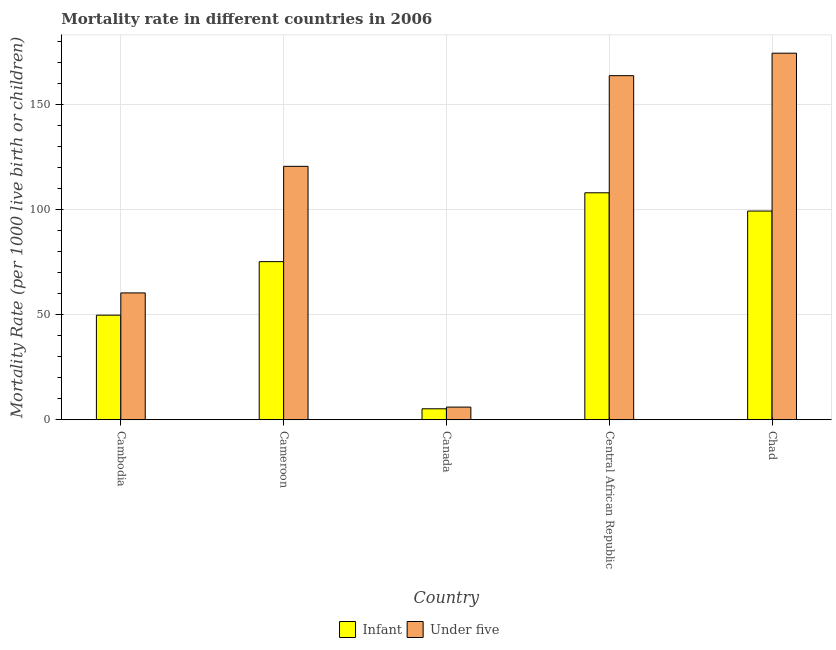How many groups of bars are there?
Give a very brief answer. 5. Are the number of bars on each tick of the X-axis equal?
Your answer should be very brief. Yes. In how many cases, is the number of bars for a given country not equal to the number of legend labels?
Give a very brief answer. 0. What is the infant mortality rate in Canada?
Your answer should be compact. 5.2. Across all countries, what is the maximum infant mortality rate?
Offer a very short reply. 108.1. Across all countries, what is the minimum under-5 mortality rate?
Provide a short and direct response. 6. In which country was the infant mortality rate maximum?
Offer a terse response. Central African Republic. What is the total infant mortality rate in the graph?
Provide a short and direct response. 337.8. What is the difference between the under-5 mortality rate in Central African Republic and that in Chad?
Provide a short and direct response. -10.7. What is the difference between the infant mortality rate in Cambodia and the under-5 mortality rate in Cameroon?
Provide a succinct answer. -70.9. What is the average infant mortality rate per country?
Make the answer very short. 67.56. What is the difference between the under-5 mortality rate and infant mortality rate in Central African Republic?
Ensure brevity in your answer.  55.8. In how many countries, is the under-5 mortality rate greater than 50 ?
Provide a short and direct response. 4. What is the ratio of the infant mortality rate in Cameroon to that in Canada?
Offer a very short reply. 14.48. Is the infant mortality rate in Cameroon less than that in Central African Republic?
Provide a succinct answer. Yes. Is the difference between the infant mortality rate in Cambodia and Chad greater than the difference between the under-5 mortality rate in Cambodia and Chad?
Ensure brevity in your answer.  Yes. What is the difference between the highest and the second highest under-5 mortality rate?
Your answer should be compact. 10.7. What is the difference between the highest and the lowest under-5 mortality rate?
Provide a short and direct response. 168.6. In how many countries, is the infant mortality rate greater than the average infant mortality rate taken over all countries?
Provide a succinct answer. 3. What does the 2nd bar from the left in Canada represents?
Give a very brief answer. Under five. What does the 2nd bar from the right in Cambodia represents?
Keep it short and to the point. Infant. How many bars are there?
Keep it short and to the point. 10. Are all the bars in the graph horizontal?
Your answer should be compact. No. How many countries are there in the graph?
Provide a short and direct response. 5. What is the difference between two consecutive major ticks on the Y-axis?
Your answer should be very brief. 50. Does the graph contain any zero values?
Your response must be concise. No. Does the graph contain grids?
Provide a succinct answer. Yes. Where does the legend appear in the graph?
Keep it short and to the point. Bottom center. How many legend labels are there?
Make the answer very short. 2. How are the legend labels stacked?
Offer a very short reply. Horizontal. What is the title of the graph?
Your answer should be very brief. Mortality rate in different countries in 2006. What is the label or title of the Y-axis?
Ensure brevity in your answer.  Mortality Rate (per 1000 live birth or children). What is the Mortality Rate (per 1000 live birth or children) in Infant in Cambodia?
Offer a very short reply. 49.8. What is the Mortality Rate (per 1000 live birth or children) of Under five in Cambodia?
Offer a terse response. 60.4. What is the Mortality Rate (per 1000 live birth or children) of Infant in Cameroon?
Your answer should be very brief. 75.3. What is the Mortality Rate (per 1000 live birth or children) of Under five in Cameroon?
Your response must be concise. 120.7. What is the Mortality Rate (per 1000 live birth or children) of Infant in Canada?
Your answer should be very brief. 5.2. What is the Mortality Rate (per 1000 live birth or children) of Infant in Central African Republic?
Make the answer very short. 108.1. What is the Mortality Rate (per 1000 live birth or children) in Under five in Central African Republic?
Your answer should be compact. 163.9. What is the Mortality Rate (per 1000 live birth or children) in Infant in Chad?
Offer a terse response. 99.4. What is the Mortality Rate (per 1000 live birth or children) of Under five in Chad?
Provide a succinct answer. 174.6. Across all countries, what is the maximum Mortality Rate (per 1000 live birth or children) of Infant?
Make the answer very short. 108.1. Across all countries, what is the maximum Mortality Rate (per 1000 live birth or children) of Under five?
Keep it short and to the point. 174.6. What is the total Mortality Rate (per 1000 live birth or children) in Infant in the graph?
Make the answer very short. 337.8. What is the total Mortality Rate (per 1000 live birth or children) of Under five in the graph?
Give a very brief answer. 525.6. What is the difference between the Mortality Rate (per 1000 live birth or children) of Infant in Cambodia and that in Cameroon?
Your answer should be very brief. -25.5. What is the difference between the Mortality Rate (per 1000 live birth or children) of Under five in Cambodia and that in Cameroon?
Keep it short and to the point. -60.3. What is the difference between the Mortality Rate (per 1000 live birth or children) in Infant in Cambodia and that in Canada?
Offer a terse response. 44.6. What is the difference between the Mortality Rate (per 1000 live birth or children) of Under five in Cambodia and that in Canada?
Provide a short and direct response. 54.4. What is the difference between the Mortality Rate (per 1000 live birth or children) of Infant in Cambodia and that in Central African Republic?
Your answer should be compact. -58.3. What is the difference between the Mortality Rate (per 1000 live birth or children) in Under five in Cambodia and that in Central African Republic?
Your answer should be compact. -103.5. What is the difference between the Mortality Rate (per 1000 live birth or children) in Infant in Cambodia and that in Chad?
Your response must be concise. -49.6. What is the difference between the Mortality Rate (per 1000 live birth or children) in Under five in Cambodia and that in Chad?
Keep it short and to the point. -114.2. What is the difference between the Mortality Rate (per 1000 live birth or children) in Infant in Cameroon and that in Canada?
Your response must be concise. 70.1. What is the difference between the Mortality Rate (per 1000 live birth or children) of Under five in Cameroon and that in Canada?
Ensure brevity in your answer.  114.7. What is the difference between the Mortality Rate (per 1000 live birth or children) in Infant in Cameroon and that in Central African Republic?
Provide a short and direct response. -32.8. What is the difference between the Mortality Rate (per 1000 live birth or children) in Under five in Cameroon and that in Central African Republic?
Offer a terse response. -43.2. What is the difference between the Mortality Rate (per 1000 live birth or children) of Infant in Cameroon and that in Chad?
Give a very brief answer. -24.1. What is the difference between the Mortality Rate (per 1000 live birth or children) of Under five in Cameroon and that in Chad?
Ensure brevity in your answer.  -53.9. What is the difference between the Mortality Rate (per 1000 live birth or children) in Infant in Canada and that in Central African Republic?
Keep it short and to the point. -102.9. What is the difference between the Mortality Rate (per 1000 live birth or children) of Under five in Canada and that in Central African Republic?
Provide a short and direct response. -157.9. What is the difference between the Mortality Rate (per 1000 live birth or children) of Infant in Canada and that in Chad?
Provide a short and direct response. -94.2. What is the difference between the Mortality Rate (per 1000 live birth or children) of Under five in Canada and that in Chad?
Offer a very short reply. -168.6. What is the difference between the Mortality Rate (per 1000 live birth or children) of Under five in Central African Republic and that in Chad?
Provide a succinct answer. -10.7. What is the difference between the Mortality Rate (per 1000 live birth or children) in Infant in Cambodia and the Mortality Rate (per 1000 live birth or children) in Under five in Cameroon?
Offer a very short reply. -70.9. What is the difference between the Mortality Rate (per 1000 live birth or children) in Infant in Cambodia and the Mortality Rate (per 1000 live birth or children) in Under five in Canada?
Your response must be concise. 43.8. What is the difference between the Mortality Rate (per 1000 live birth or children) of Infant in Cambodia and the Mortality Rate (per 1000 live birth or children) of Under five in Central African Republic?
Provide a short and direct response. -114.1. What is the difference between the Mortality Rate (per 1000 live birth or children) in Infant in Cambodia and the Mortality Rate (per 1000 live birth or children) in Under five in Chad?
Ensure brevity in your answer.  -124.8. What is the difference between the Mortality Rate (per 1000 live birth or children) of Infant in Cameroon and the Mortality Rate (per 1000 live birth or children) of Under five in Canada?
Offer a terse response. 69.3. What is the difference between the Mortality Rate (per 1000 live birth or children) of Infant in Cameroon and the Mortality Rate (per 1000 live birth or children) of Under five in Central African Republic?
Keep it short and to the point. -88.6. What is the difference between the Mortality Rate (per 1000 live birth or children) in Infant in Cameroon and the Mortality Rate (per 1000 live birth or children) in Under five in Chad?
Keep it short and to the point. -99.3. What is the difference between the Mortality Rate (per 1000 live birth or children) in Infant in Canada and the Mortality Rate (per 1000 live birth or children) in Under five in Central African Republic?
Offer a terse response. -158.7. What is the difference between the Mortality Rate (per 1000 live birth or children) of Infant in Canada and the Mortality Rate (per 1000 live birth or children) of Under five in Chad?
Your answer should be compact. -169.4. What is the difference between the Mortality Rate (per 1000 live birth or children) in Infant in Central African Republic and the Mortality Rate (per 1000 live birth or children) in Under five in Chad?
Your response must be concise. -66.5. What is the average Mortality Rate (per 1000 live birth or children) of Infant per country?
Offer a very short reply. 67.56. What is the average Mortality Rate (per 1000 live birth or children) in Under five per country?
Offer a terse response. 105.12. What is the difference between the Mortality Rate (per 1000 live birth or children) in Infant and Mortality Rate (per 1000 live birth or children) in Under five in Cambodia?
Your answer should be compact. -10.6. What is the difference between the Mortality Rate (per 1000 live birth or children) in Infant and Mortality Rate (per 1000 live birth or children) in Under five in Cameroon?
Keep it short and to the point. -45.4. What is the difference between the Mortality Rate (per 1000 live birth or children) of Infant and Mortality Rate (per 1000 live birth or children) of Under five in Canada?
Give a very brief answer. -0.8. What is the difference between the Mortality Rate (per 1000 live birth or children) in Infant and Mortality Rate (per 1000 live birth or children) in Under five in Central African Republic?
Your answer should be compact. -55.8. What is the difference between the Mortality Rate (per 1000 live birth or children) in Infant and Mortality Rate (per 1000 live birth or children) in Under five in Chad?
Give a very brief answer. -75.2. What is the ratio of the Mortality Rate (per 1000 live birth or children) of Infant in Cambodia to that in Cameroon?
Your answer should be very brief. 0.66. What is the ratio of the Mortality Rate (per 1000 live birth or children) of Under five in Cambodia to that in Cameroon?
Your response must be concise. 0.5. What is the ratio of the Mortality Rate (per 1000 live birth or children) in Infant in Cambodia to that in Canada?
Give a very brief answer. 9.58. What is the ratio of the Mortality Rate (per 1000 live birth or children) of Under five in Cambodia to that in Canada?
Provide a short and direct response. 10.07. What is the ratio of the Mortality Rate (per 1000 live birth or children) in Infant in Cambodia to that in Central African Republic?
Your answer should be compact. 0.46. What is the ratio of the Mortality Rate (per 1000 live birth or children) of Under five in Cambodia to that in Central African Republic?
Give a very brief answer. 0.37. What is the ratio of the Mortality Rate (per 1000 live birth or children) in Infant in Cambodia to that in Chad?
Your response must be concise. 0.5. What is the ratio of the Mortality Rate (per 1000 live birth or children) of Under five in Cambodia to that in Chad?
Give a very brief answer. 0.35. What is the ratio of the Mortality Rate (per 1000 live birth or children) of Infant in Cameroon to that in Canada?
Give a very brief answer. 14.48. What is the ratio of the Mortality Rate (per 1000 live birth or children) of Under five in Cameroon to that in Canada?
Your response must be concise. 20.12. What is the ratio of the Mortality Rate (per 1000 live birth or children) of Infant in Cameroon to that in Central African Republic?
Provide a short and direct response. 0.7. What is the ratio of the Mortality Rate (per 1000 live birth or children) in Under five in Cameroon to that in Central African Republic?
Your response must be concise. 0.74. What is the ratio of the Mortality Rate (per 1000 live birth or children) in Infant in Cameroon to that in Chad?
Offer a very short reply. 0.76. What is the ratio of the Mortality Rate (per 1000 live birth or children) of Under five in Cameroon to that in Chad?
Your answer should be compact. 0.69. What is the ratio of the Mortality Rate (per 1000 live birth or children) in Infant in Canada to that in Central African Republic?
Offer a very short reply. 0.05. What is the ratio of the Mortality Rate (per 1000 live birth or children) of Under five in Canada to that in Central African Republic?
Keep it short and to the point. 0.04. What is the ratio of the Mortality Rate (per 1000 live birth or children) of Infant in Canada to that in Chad?
Your response must be concise. 0.05. What is the ratio of the Mortality Rate (per 1000 live birth or children) in Under five in Canada to that in Chad?
Ensure brevity in your answer.  0.03. What is the ratio of the Mortality Rate (per 1000 live birth or children) in Infant in Central African Republic to that in Chad?
Make the answer very short. 1.09. What is the ratio of the Mortality Rate (per 1000 live birth or children) in Under five in Central African Republic to that in Chad?
Ensure brevity in your answer.  0.94. What is the difference between the highest and the lowest Mortality Rate (per 1000 live birth or children) in Infant?
Make the answer very short. 102.9. What is the difference between the highest and the lowest Mortality Rate (per 1000 live birth or children) in Under five?
Offer a terse response. 168.6. 